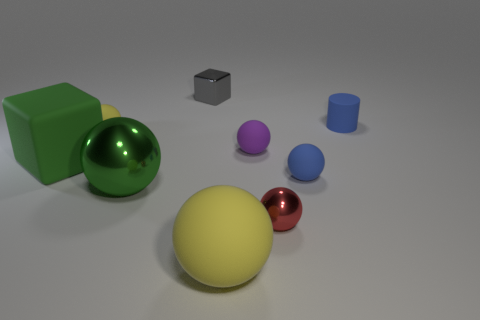There is a red metal thing on the right side of the matte block; is it the same shape as the small gray object?
Keep it short and to the point. No. The metallic ball to the left of the large yellow rubber sphere is what color?
Your answer should be compact. Green. There is a big green thing that is made of the same material as the purple thing; what is its shape?
Ensure brevity in your answer.  Cube. Are there any other things that are the same color as the small rubber cylinder?
Your response must be concise. Yes. Is the number of small spheres that are left of the tiny red metallic ball greater than the number of tiny matte balls that are to the right of the small cube?
Your answer should be compact. No. How many green shiny objects have the same size as the purple rubber ball?
Offer a terse response. 0. Is the number of tiny blue spheres behind the blue rubber cylinder less than the number of red shiny spheres that are to the right of the big yellow ball?
Provide a succinct answer. Yes. Is there a red shiny object of the same shape as the tiny purple object?
Provide a short and direct response. Yes. Is the green shiny thing the same shape as the green rubber object?
Offer a terse response. No. How many tiny things are blue rubber spheres or purple things?
Your response must be concise. 2. 